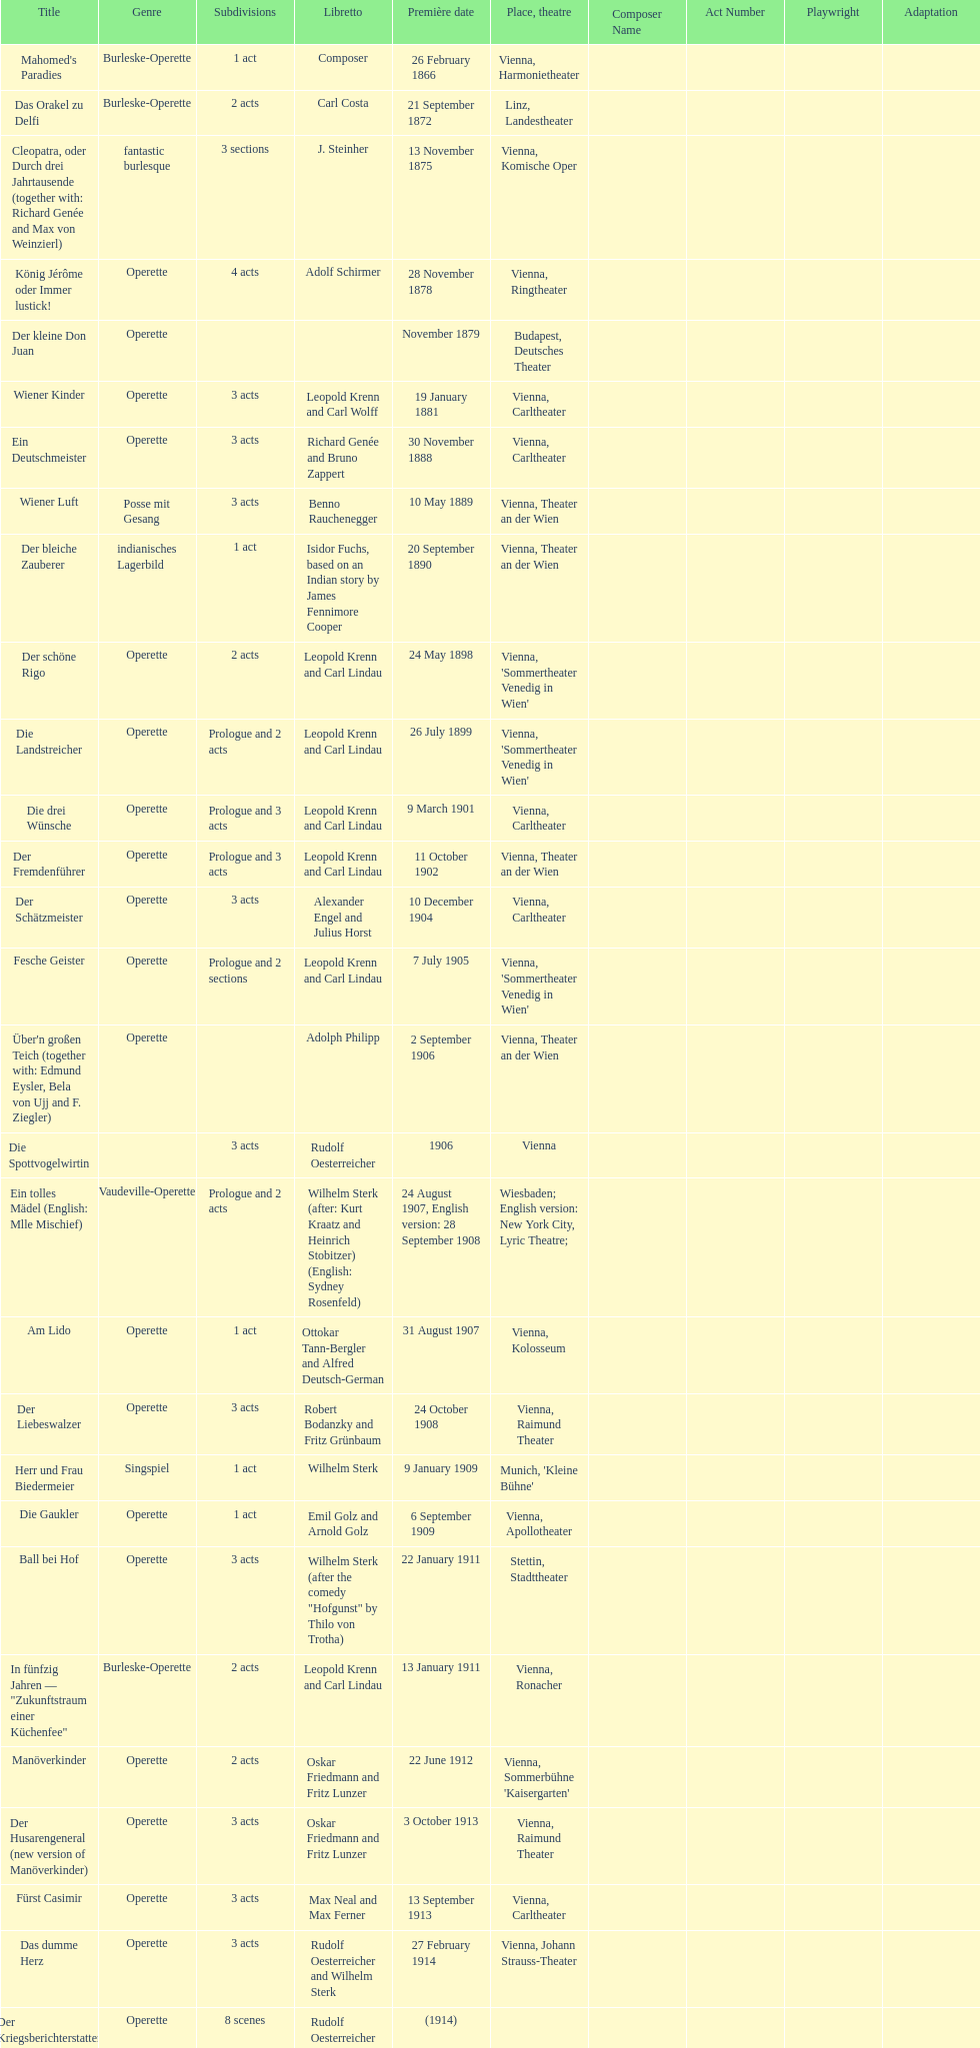Does der liebeswalzer or manöverkinder contain more acts? Der Liebeswalzer. 